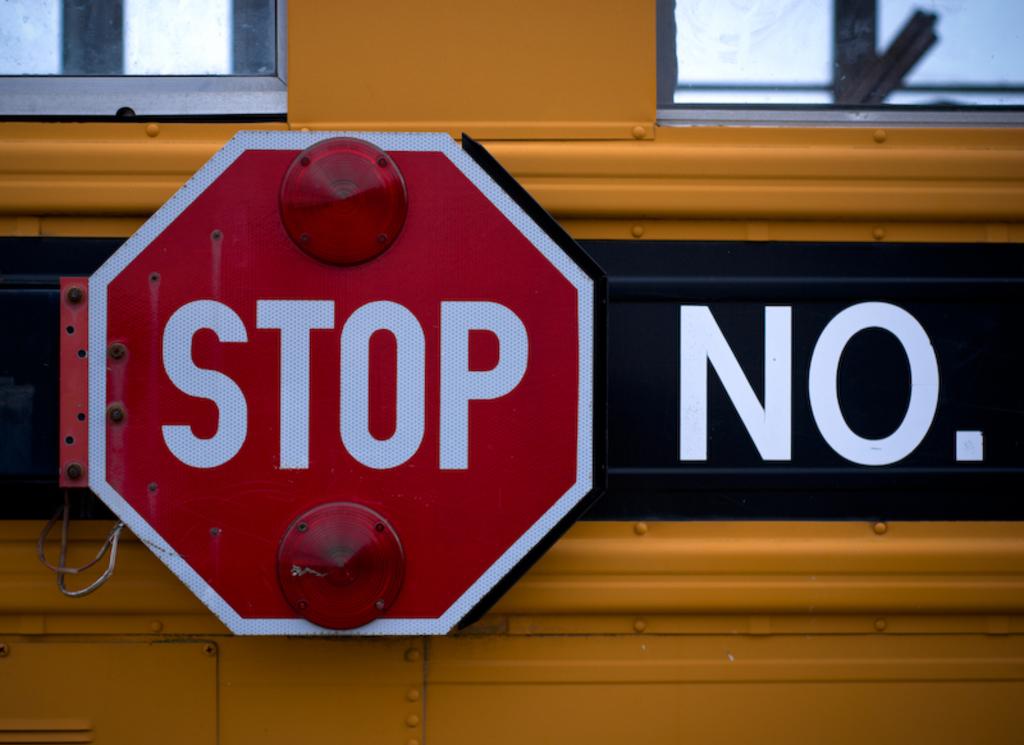Do the lights work on the stop sign?
Keep it short and to the point. No. What instruction is written on the red sign?
Offer a terse response. Stop. 